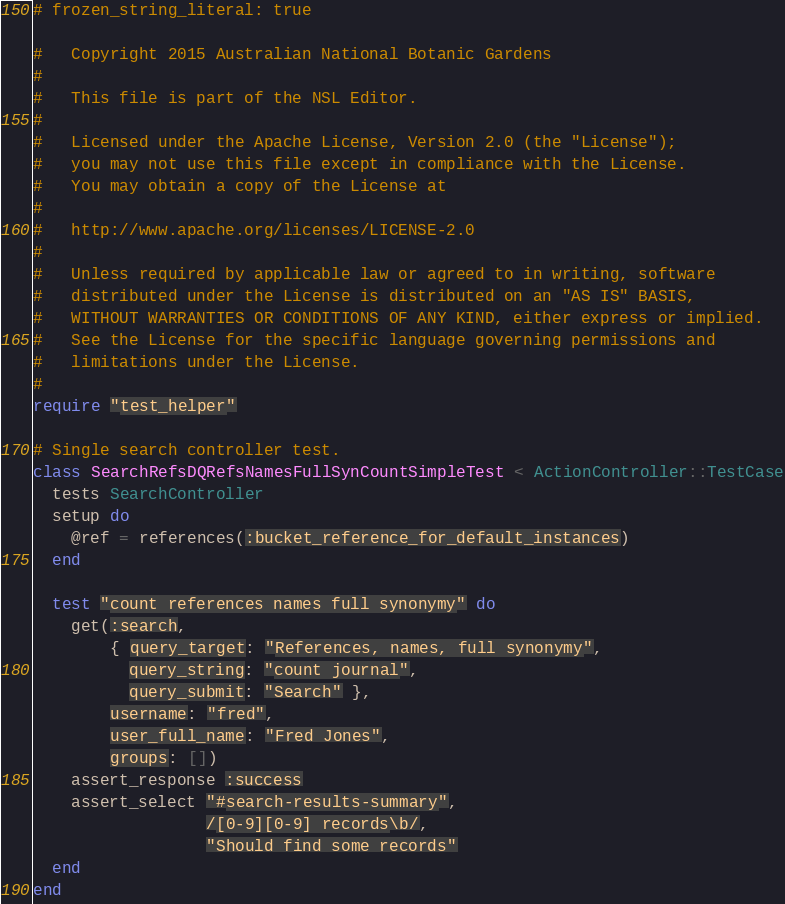<code> <loc_0><loc_0><loc_500><loc_500><_Ruby_># frozen_string_literal: true

#   Copyright 2015 Australian National Botanic Gardens
#
#   This file is part of the NSL Editor.
#
#   Licensed under the Apache License, Version 2.0 (the "License");
#   you may not use this file except in compliance with the License.
#   You may obtain a copy of the License at
#
#   http://www.apache.org/licenses/LICENSE-2.0
#
#   Unless required by applicable law or agreed to in writing, software
#   distributed under the License is distributed on an "AS IS" BASIS,
#   WITHOUT WARRANTIES OR CONDITIONS OF ANY KIND, either express or implied.
#   See the License for the specific language governing permissions and
#   limitations under the License.
#
require "test_helper"

# Single search controller test.
class SearchRefsDQRefsNamesFullSynCountSimpleTest < ActionController::TestCase
  tests SearchController
  setup do
    @ref = references(:bucket_reference_for_default_instances)
  end

  test "count references names full synonymy" do
    get(:search,
        { query_target: "References, names, full synonymy",
          query_string: "count journal",
          query_submit: "Search" },
        username: "fred",
        user_full_name: "Fred Jones",
        groups: [])
    assert_response :success
    assert_select "#search-results-summary",
                  /[0-9][0-9] records\b/,
                  "Should find some records"
  end
end
</code> 